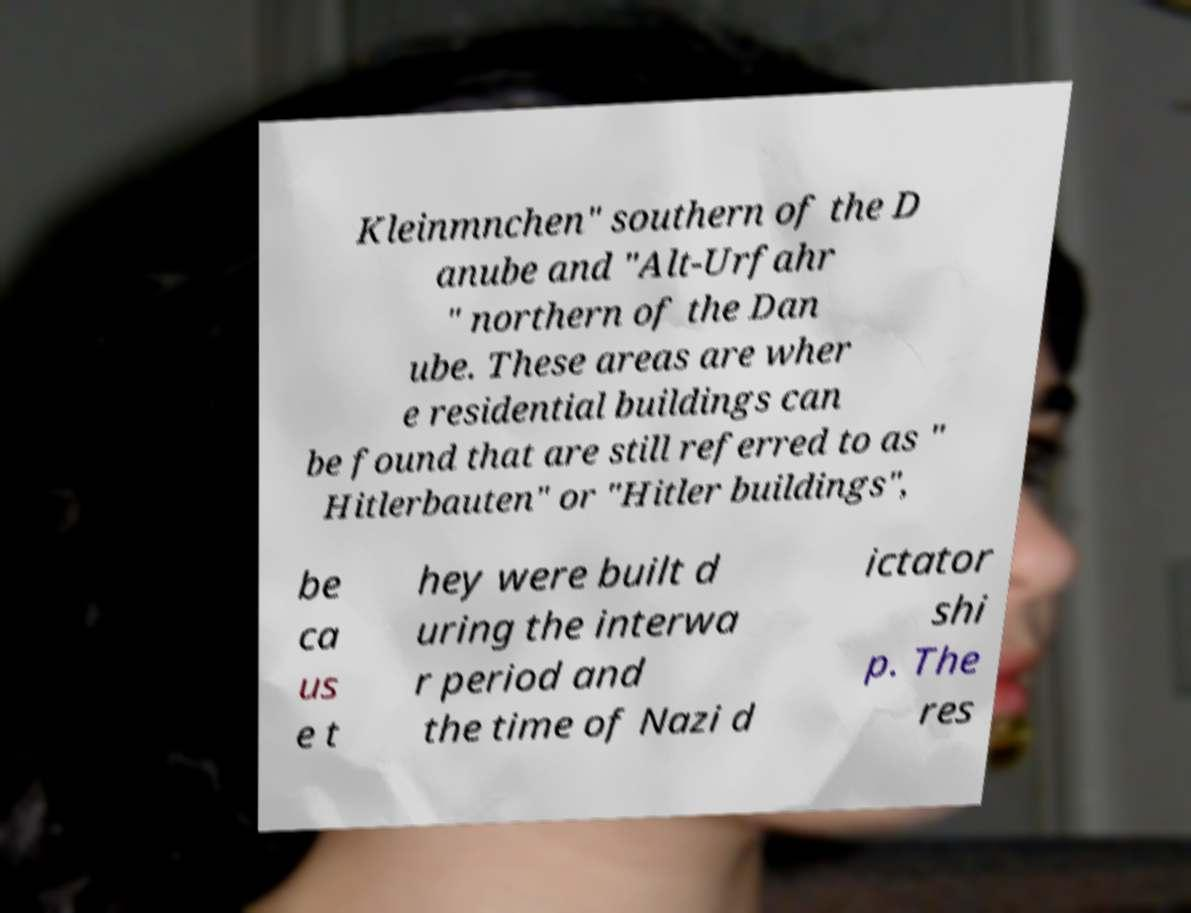I need the written content from this picture converted into text. Can you do that? Kleinmnchen" southern of the D anube and "Alt-Urfahr " northern of the Dan ube. These areas are wher e residential buildings can be found that are still referred to as " Hitlerbauten" or "Hitler buildings", be ca us e t hey were built d uring the interwa r period and the time of Nazi d ictator shi p. The res 